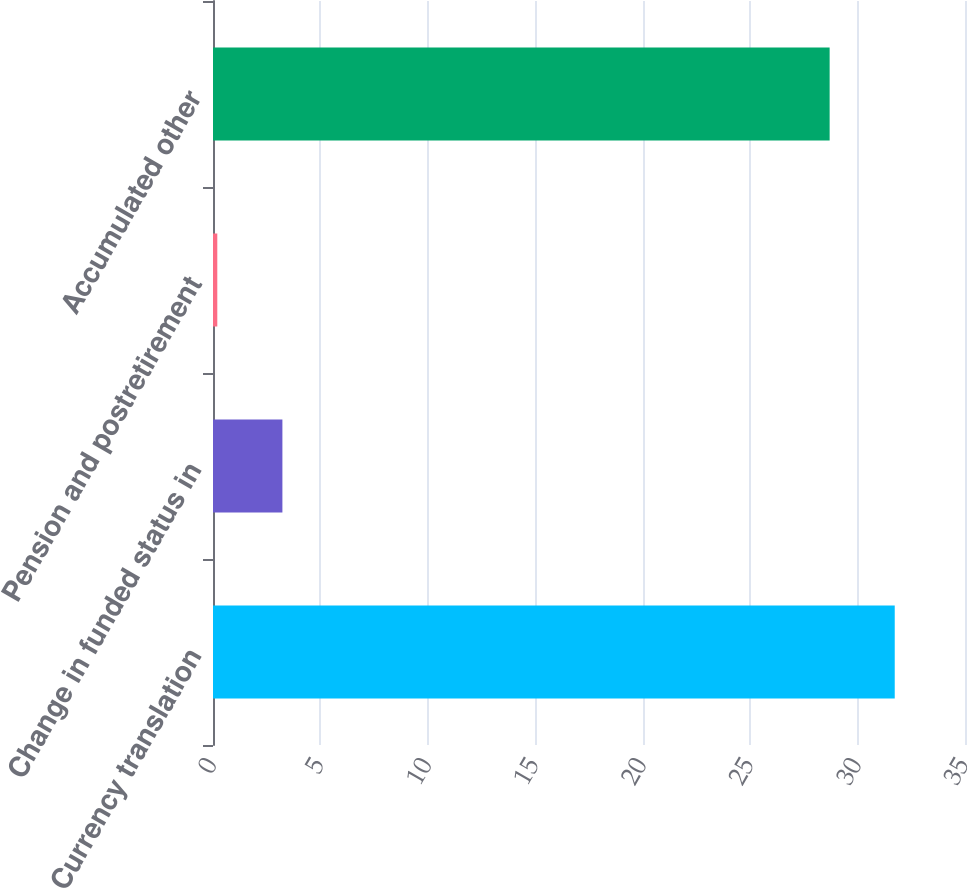Convert chart to OTSL. <chart><loc_0><loc_0><loc_500><loc_500><bar_chart><fcel>Currency translation<fcel>Change in funded status in<fcel>Pension and postretirement<fcel>Accumulated other<nl><fcel>31.73<fcel>3.23<fcel>0.2<fcel>28.7<nl></chart> 